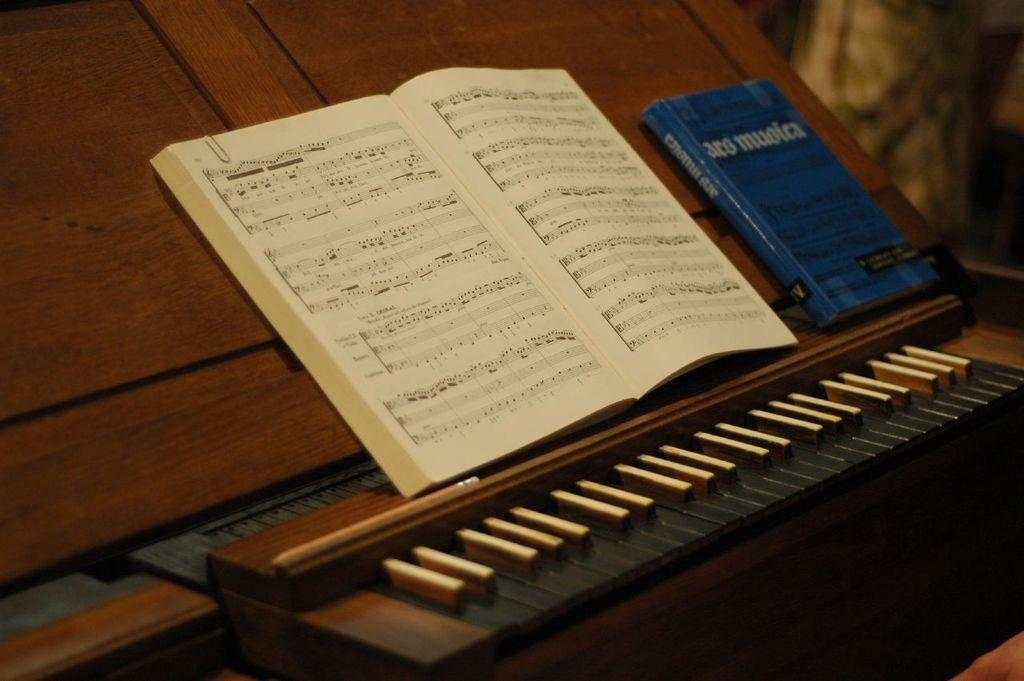What is placed on top of the piano in the image? There is a picture placed on top of a piano. What can be seen to the right of the image? There is a blue color book to the right of the image. Can you see a locket hanging from the piano in the image? There is no locket hanging from the piano in the image. Are there any signs of waste or litter in the image? There is no indication of waste or litter in the image. Is there a snail crawling on the blue color book in the image? There is no snail present in the image. 